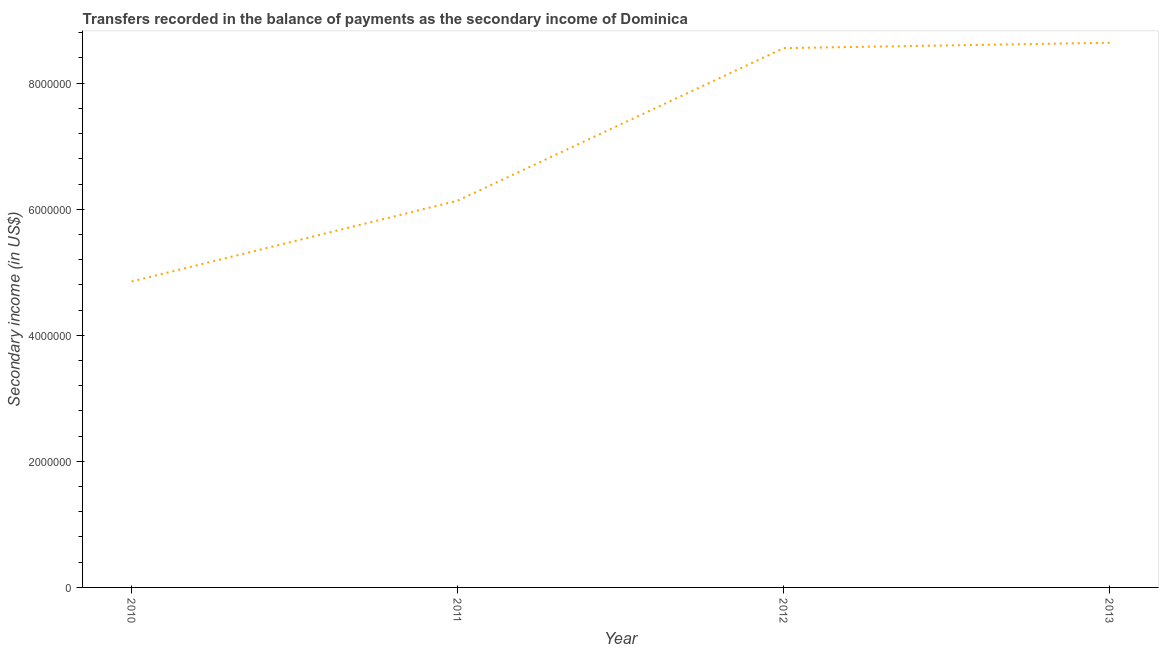What is the amount of secondary income in 2012?
Your answer should be compact. 8.56e+06. Across all years, what is the maximum amount of secondary income?
Your response must be concise. 8.64e+06. Across all years, what is the minimum amount of secondary income?
Offer a very short reply. 4.85e+06. In which year was the amount of secondary income maximum?
Offer a very short reply. 2013. In which year was the amount of secondary income minimum?
Give a very brief answer. 2010. What is the sum of the amount of secondary income?
Give a very brief answer. 2.82e+07. What is the difference between the amount of secondary income in 2010 and 2011?
Offer a terse response. -1.28e+06. What is the average amount of secondary income per year?
Your answer should be compact. 7.05e+06. What is the median amount of secondary income?
Your response must be concise. 7.35e+06. Do a majority of the years between 2010 and 2011 (inclusive) have amount of secondary income greater than 5200000 US$?
Keep it short and to the point. No. What is the ratio of the amount of secondary income in 2011 to that in 2013?
Provide a short and direct response. 0.71. Is the amount of secondary income in 2011 less than that in 2013?
Offer a terse response. Yes. What is the difference between the highest and the second highest amount of secondary income?
Your answer should be compact. 8.50e+04. What is the difference between the highest and the lowest amount of secondary income?
Your response must be concise. 3.79e+06. In how many years, is the amount of secondary income greater than the average amount of secondary income taken over all years?
Your answer should be compact. 2. How many years are there in the graph?
Your answer should be very brief. 4. Does the graph contain any zero values?
Offer a very short reply. No. What is the title of the graph?
Your answer should be compact. Transfers recorded in the balance of payments as the secondary income of Dominica. What is the label or title of the Y-axis?
Make the answer very short. Secondary income (in US$). What is the Secondary income (in US$) in 2010?
Offer a terse response. 4.85e+06. What is the Secondary income (in US$) in 2011?
Your response must be concise. 6.14e+06. What is the Secondary income (in US$) in 2012?
Ensure brevity in your answer.  8.56e+06. What is the Secondary income (in US$) in 2013?
Offer a terse response. 8.64e+06. What is the difference between the Secondary income (in US$) in 2010 and 2011?
Offer a very short reply. -1.28e+06. What is the difference between the Secondary income (in US$) in 2010 and 2012?
Your answer should be compact. -3.70e+06. What is the difference between the Secondary income (in US$) in 2010 and 2013?
Provide a succinct answer. -3.79e+06. What is the difference between the Secondary income (in US$) in 2011 and 2012?
Give a very brief answer. -2.42e+06. What is the difference between the Secondary income (in US$) in 2011 and 2013?
Keep it short and to the point. -2.50e+06. What is the difference between the Secondary income (in US$) in 2012 and 2013?
Make the answer very short. -8.50e+04. What is the ratio of the Secondary income (in US$) in 2010 to that in 2011?
Offer a very short reply. 0.79. What is the ratio of the Secondary income (in US$) in 2010 to that in 2012?
Offer a very short reply. 0.57. What is the ratio of the Secondary income (in US$) in 2010 to that in 2013?
Your answer should be very brief. 0.56. What is the ratio of the Secondary income (in US$) in 2011 to that in 2012?
Ensure brevity in your answer.  0.72. What is the ratio of the Secondary income (in US$) in 2011 to that in 2013?
Make the answer very short. 0.71. What is the ratio of the Secondary income (in US$) in 2012 to that in 2013?
Make the answer very short. 0.99. 